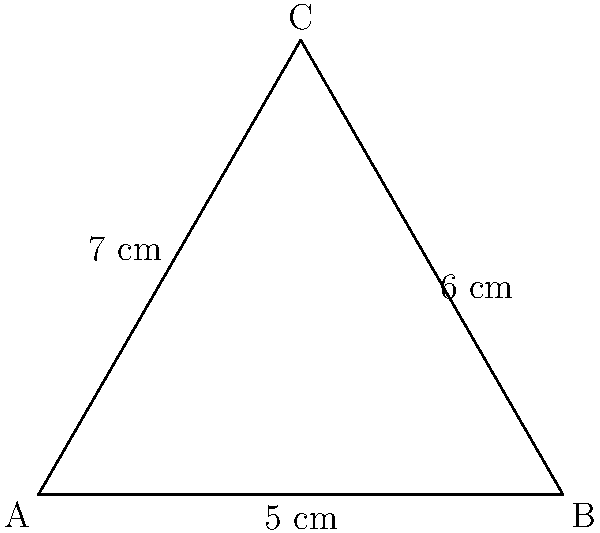As part of your workplace safety initiative, you need to calculate the perimeter of a triangular "caution" sign. The sign has sides measuring 5 cm, 6 cm, and 7 cm. What is the perimeter of the sign in centimeters? To calculate the perimeter of a triangle, we need to add the lengths of all three sides. This problem is straightforward and doesn't require any complex calculations, making it an excellent exercise for practicing basic addition and reinforcing the concept of perimeter.

Step 1: Identify the lengths of all sides
Side 1 = 5 cm
Side 2 = 6 cm
Side 3 = 7 cm

Step 2: Add the lengths of all sides
Perimeter = Side 1 + Side 2 + Side 3
Perimeter = 5 cm + 6 cm + 7 cm
Perimeter = 18 cm

Therefore, the perimeter of the triangular "caution" sign is 18 cm.

This simple calculation demonstrates how basic math skills can be applied to real-world situations in business and workplace safety. It's a reminder that maintaining clear thinking and attention to detail is crucial in both personal recovery and professional responsibilities.
Answer: 18 cm 